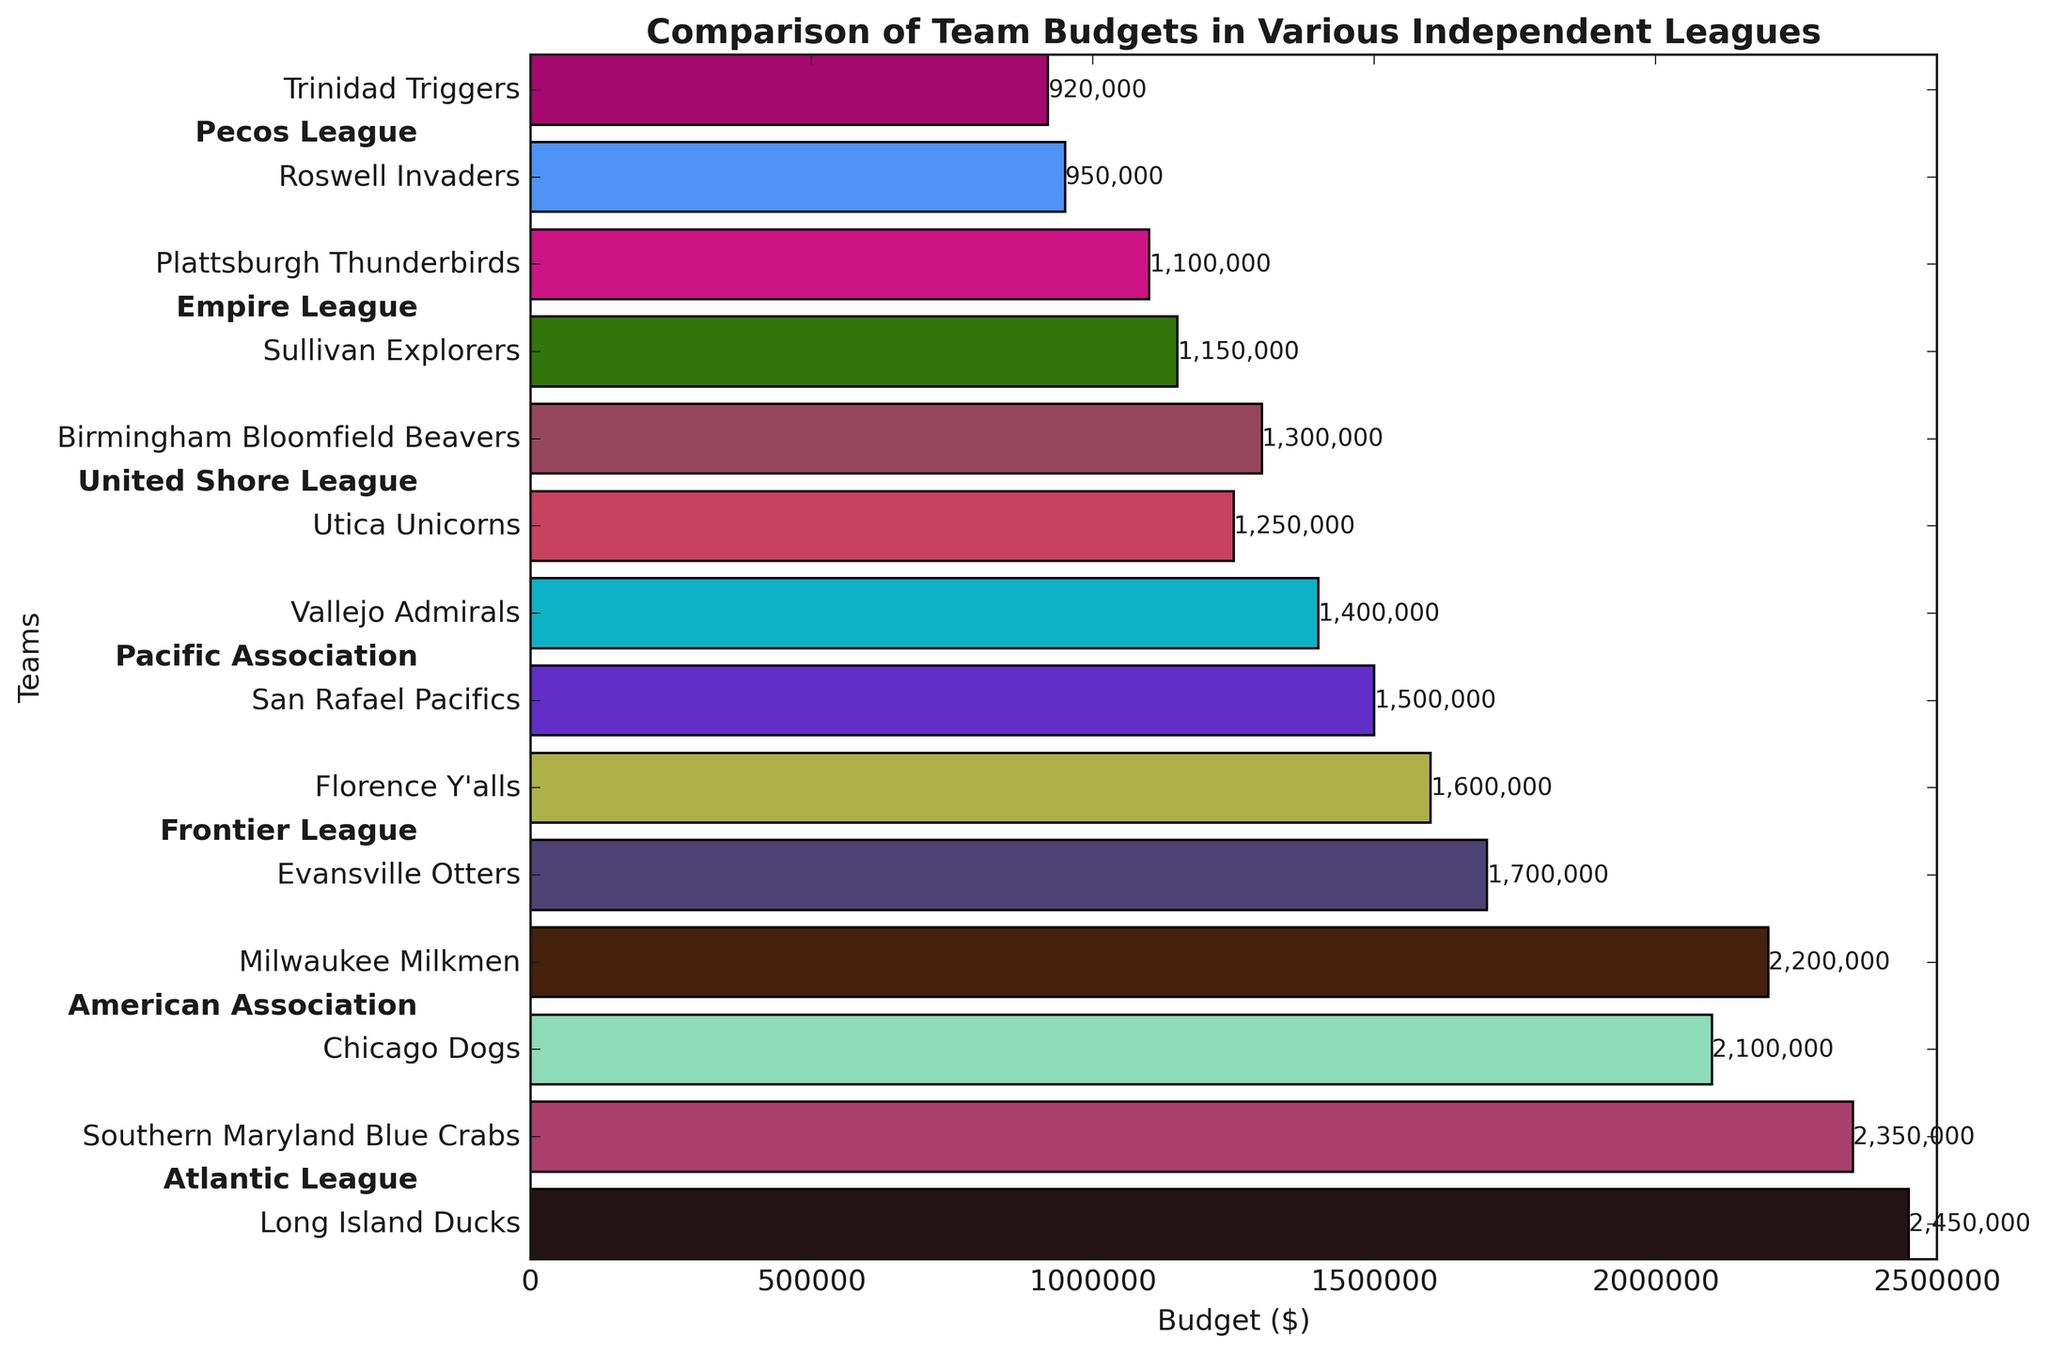Which team has the highest budget? The team with the highest budget is determined by the length of the bar that extends the farthest to the right. In this case, it is the Long Island Ducks from the Atlantic League.
Answer: Long Island Ducks Which league has the lowest average budget? Calculate the average budget for each league by summing the budgets of teams within each league and dividing by the number of teams in that league. The Empire League has the lowest average budget with (1150000 + 1100000) / 2 = 1125000.
Answer: Empire League What is the total budget for teams in the American Association? Add the budgets for the Chicago Dogs and Milwaukee Milkmen. Total budget = 2100000 + 2200000 = 4300000.
Answer: 4300000 How much more is the budget of the Long Island Ducks than the Roswell Invaders? Subtract the budget of the Roswell Invaders from the budget of the Long Island Ducks. Difference = 2450000 - 950000 = 1500000.
Answer: 1500000 Which team's budget is closest to the average budget of the teams in the Frontier League? Calculate the average budget of the Frontier League teams: (1700000 + 1600000) / 2 = 1650000. The Evansville Otters' budget of 1700000 is closest to this average.
Answer: Evansville Otters How many teams have a budget less than 1,300,000? Count the number of bars that are shorter than this length. There are 5 teams: Utica Unicorns, Birmingham Bloomfield Beavers, Sullivan Explorers, Plattsburgh Thunderbirds, and Trinidad Triggers.
Answer: 5 Which league's team appears first and last in the bar chart? The first team on the y-axis is the Long Island Ducks from the Atlantic League, and the last team is the Trinidad Triggers from the Pecos League.
Answer: Atlantic League and Pecos League By how much does the budget of the top team (Long Island Ducks) exceed the combined budget of the two bottom teams (Roswell Invaders and Trinidad Triggers)? Calculate the combined budget of Roswell Invaders and Trinidad Triggers: 950000 + 920000 = 1870000. Subtract this value from the budget of Long Island Ducks: 2450000 - 1870000 = 580000.
Answer: 580000 